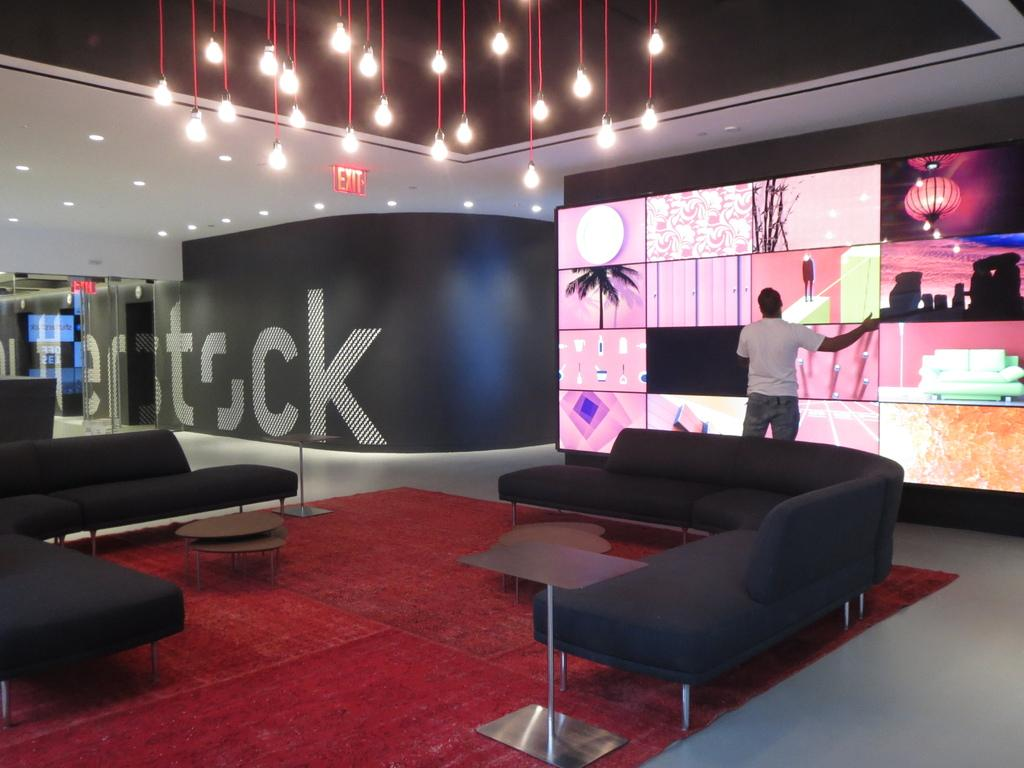What type of furniture is on the floor in the image? There is a sofa on the floor in the image. What is located above the sofa? There are lights above the sofa. Can you describe the person in the image? A person is standing in the image. What is the purpose of the projector screen in the image? The projector screen is likely used for displaying images or videos. How does the person in the image tie a knot with the chalk? There is no chalk or knot-tying activity present in the image. 